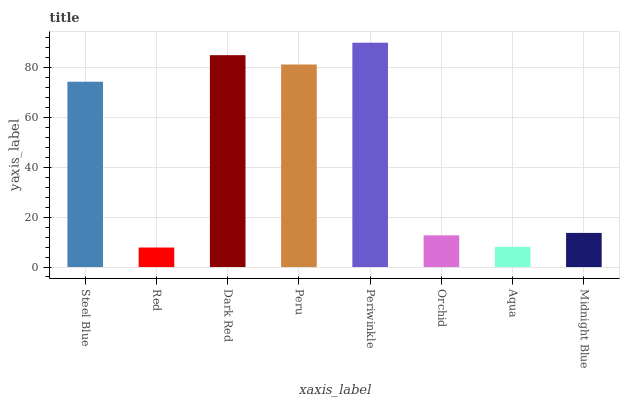Is Dark Red the minimum?
Answer yes or no. No. Is Dark Red the maximum?
Answer yes or no. No. Is Dark Red greater than Red?
Answer yes or no. Yes. Is Red less than Dark Red?
Answer yes or no. Yes. Is Red greater than Dark Red?
Answer yes or no. No. Is Dark Red less than Red?
Answer yes or no. No. Is Steel Blue the high median?
Answer yes or no. Yes. Is Midnight Blue the low median?
Answer yes or no. Yes. Is Periwinkle the high median?
Answer yes or no. No. Is Periwinkle the low median?
Answer yes or no. No. 